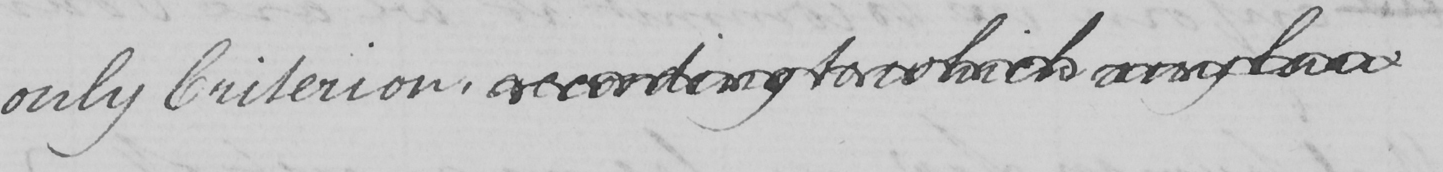What does this handwritten line say? only Criterion , according to which any law 